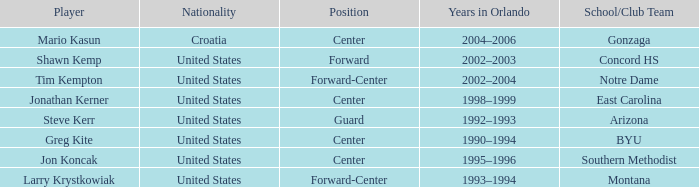Could you parse the entire table? {'header': ['Player', 'Nationality', 'Position', 'Years in Orlando', 'School/Club Team'], 'rows': [['Mario Kasun', 'Croatia', 'Center', '2004–2006', 'Gonzaga'], ['Shawn Kemp', 'United States', 'Forward', '2002–2003', 'Concord HS'], ['Tim Kempton', 'United States', 'Forward-Center', '2002–2004', 'Notre Dame'], ['Jonathan Kerner', 'United States', 'Center', '1998–1999', 'East Carolina'], ['Steve Kerr', 'United States', 'Guard', '1992–1993', 'Arizona'], ['Greg Kite', 'United States', 'Center', '1990–1994', 'BYU'], ['Jon Koncak', 'United States', 'Center', '1995–1996', 'Southern Methodist'], ['Larry Krystkowiak', 'United States', 'Forward-Center', '1993–1994', 'Montana']]} What school/club team has tim kempton as the player? Notre Dame. 